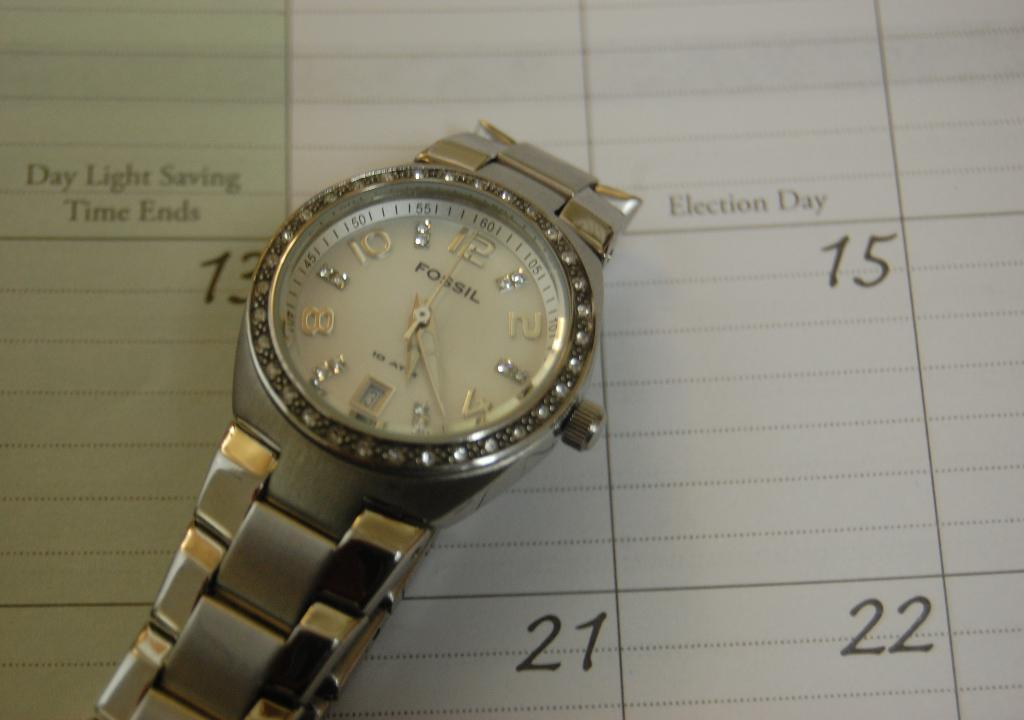<image>
Summarize the visual content of the image. A silver Fossil brand watch laying on top of a calendar. 